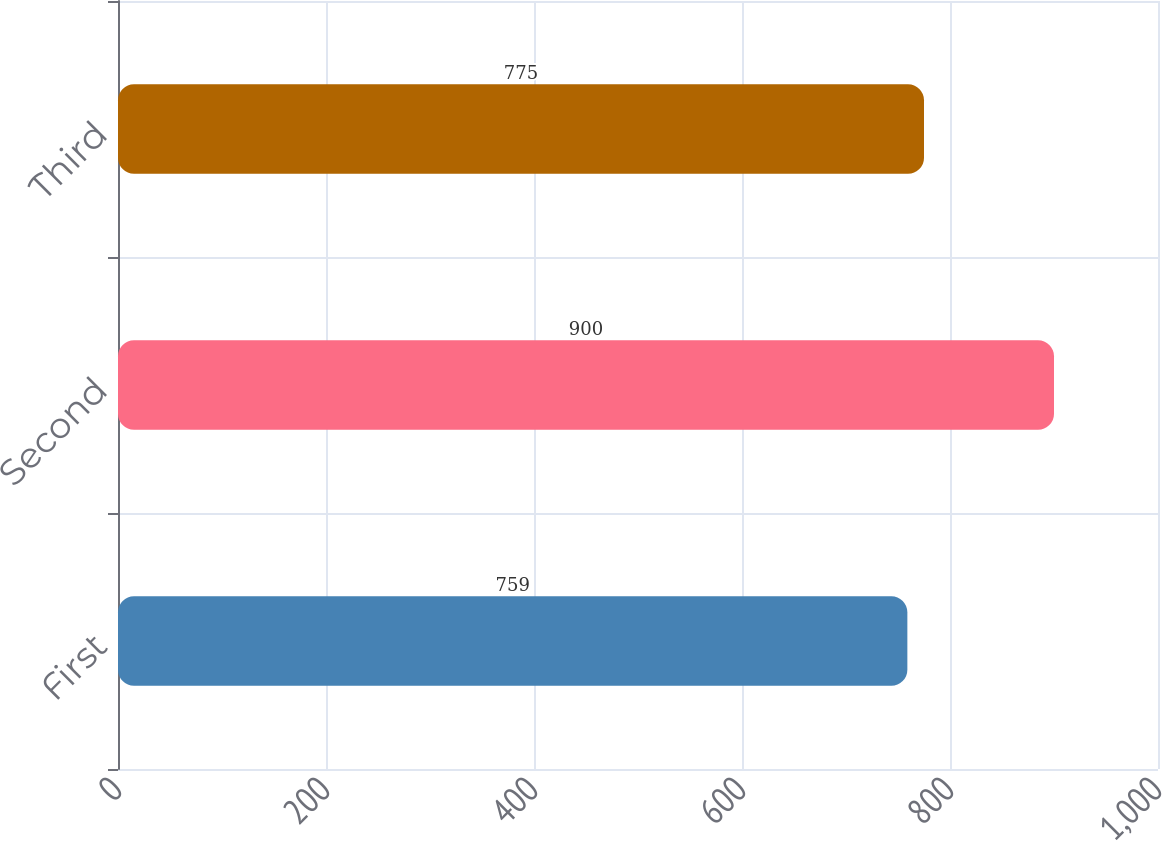<chart> <loc_0><loc_0><loc_500><loc_500><bar_chart><fcel>First<fcel>Second<fcel>Third<nl><fcel>759<fcel>900<fcel>775<nl></chart> 